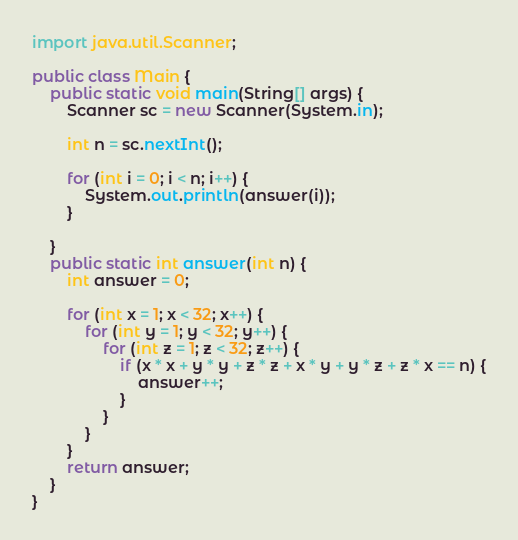<code> <loc_0><loc_0><loc_500><loc_500><_Java_>import java.util.Scanner;
        
public class Main {
    public static void main(String[] args) {
        Scanner sc = new Scanner(System.in);
        
        int n = sc.nextInt();

        for (int i = 0; i < n; i++) {
            System.out.println(answer(i));
        }
        
    }
    public static int answer(int n) {
        int answer = 0;

        for (int x = 1; x < 32; x++) {
            for (int y = 1; y < 32; y++) {
                for (int z = 1; z < 32; z++) {
                    if (x * x + y * y + z * z + x * y + y * z + z * x == n) {
                        answer++;
                    }
                }
            }
        }
        return answer;
    }
}</code> 